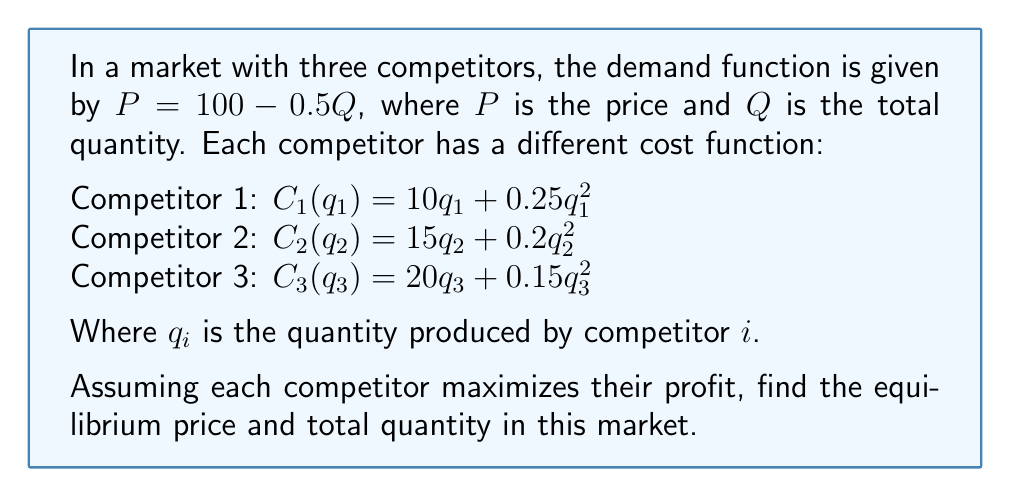Solve this math problem. Let's approach this step-by-step:

1) First, we need to set up the profit functions for each competitor:
   $\pi_i = Pq_i - C_i(q_i)$

2) The total quantity $Q = q_1 + q_2 + q_3$

3) To maximize profit, we set the derivative of each profit function to zero:

   For Competitor 1:
   $$\frac{d\pi_1}{dq_1} = P - \frac{dP}{dQ}q_1 - \frac{dC_1}{dq_1} = 0$$
   $$(100 - 0.5Q) - 0.5q_1 - (10 + 0.5q_1) = 0$$
   $$90 - 0.5Q - q_1 = 0$$

   Similarly for Competitors 2 and 3:
   $$85 - 0.5Q - 0.4q_2 = 0$$
   $$80 - 0.5Q - 0.3q_3 = 0$$

4) We now have a system of 4 equations with 4 unknowns:
   $$90 - 0.5Q - q_1 = 0$$
   $$85 - 0.5Q - 0.4q_2 = 0$$
   $$80 - 0.5Q - 0.3q_3 = 0$$
   $$Q = q_1 + q_2 + q_3$$

5) Solving this system (using substitution or a computer algebra system):
   $$q_1 \approx 55.17$$
   $$q_2 \approx 62.07$$
   $$q_3 \approx 68.97$$
   $$Q \approx 186.21$$

6) The equilibrium price can be found by substituting Q into the demand function:
   $$P = 100 - 0.5(186.21) \approx 6.90$$

Therefore, the equilibrium price is approximately $6.90, and the total quantity is approximately 186.21.
Answer: Price ≈ $6.90, Quantity ≈ 186.21 